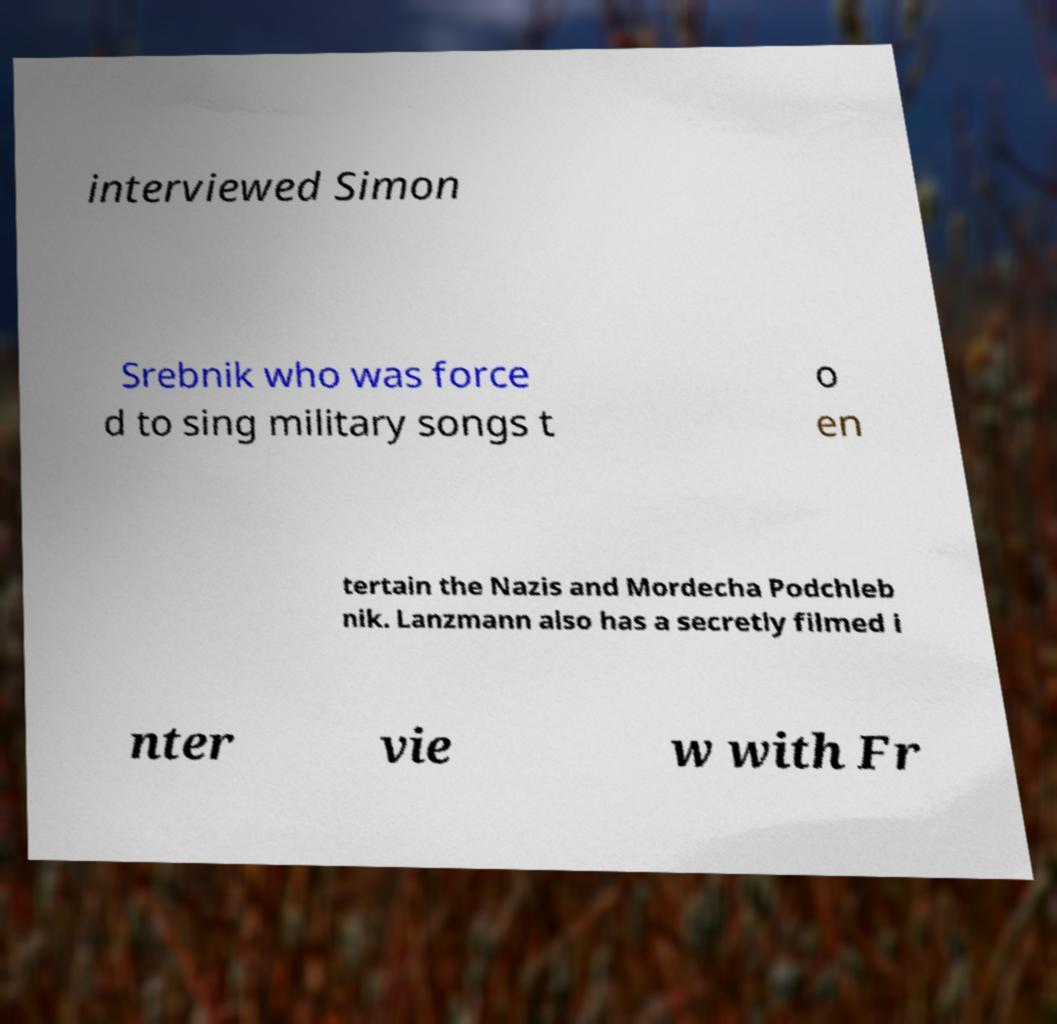Please read and relay the text visible in this image. What does it say? interviewed Simon Srebnik who was force d to sing military songs t o en tertain the Nazis and Mordecha Podchleb nik. Lanzmann also has a secretly filmed i nter vie w with Fr 